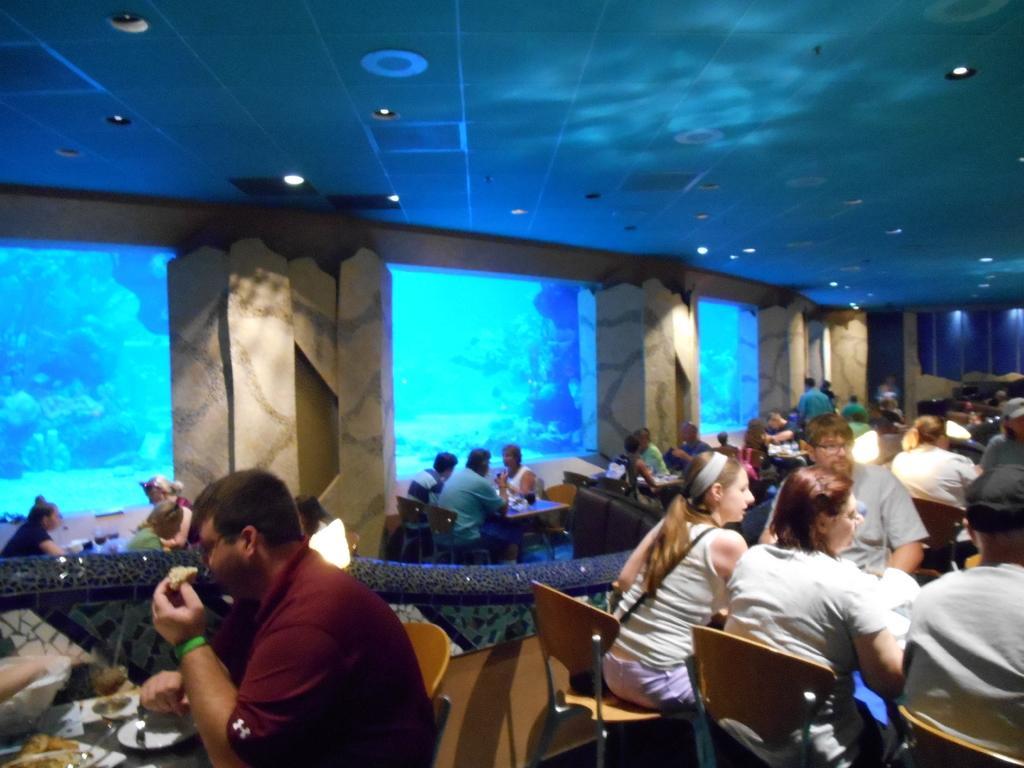Can you describe this image briefly? In this picture there are few persons sitting in chairs and there is a table in front of them which has few objects placed on it. 